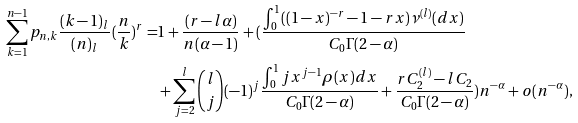Convert formula to latex. <formula><loc_0><loc_0><loc_500><loc_500>\sum _ { k = 1 } ^ { n - 1 } p _ { n , k } \frac { ( k - 1 ) _ { l } } { ( n ) _ { l } } ( \frac { n } { k } ) ^ { r } = & 1 + \frac { ( r - l \alpha ) } { n ( \alpha - 1 ) } + ( \frac { \int _ { 0 } ^ { 1 } ( ( 1 - x ) ^ { - r } - 1 - r x ) \nu ^ { ( l ) } ( d x ) } { C _ { 0 } \Gamma ( 2 - \alpha ) } \\ & + \sum _ { j = 2 } ^ { l } { l \choose j } ( - 1 ) ^ { j } \frac { \int _ { 0 } ^ { 1 } j x ^ { j - 1 } \rho ( x ) d x } { C _ { 0 } \Gamma ( 2 - \alpha ) } + \frac { r C _ { 2 } ^ { ( l ) } - l C _ { 2 } } { C _ { 0 } \Gamma ( 2 - \alpha ) } ) n ^ { - \alpha } + o ( n ^ { - \alpha } ) ,</formula> 